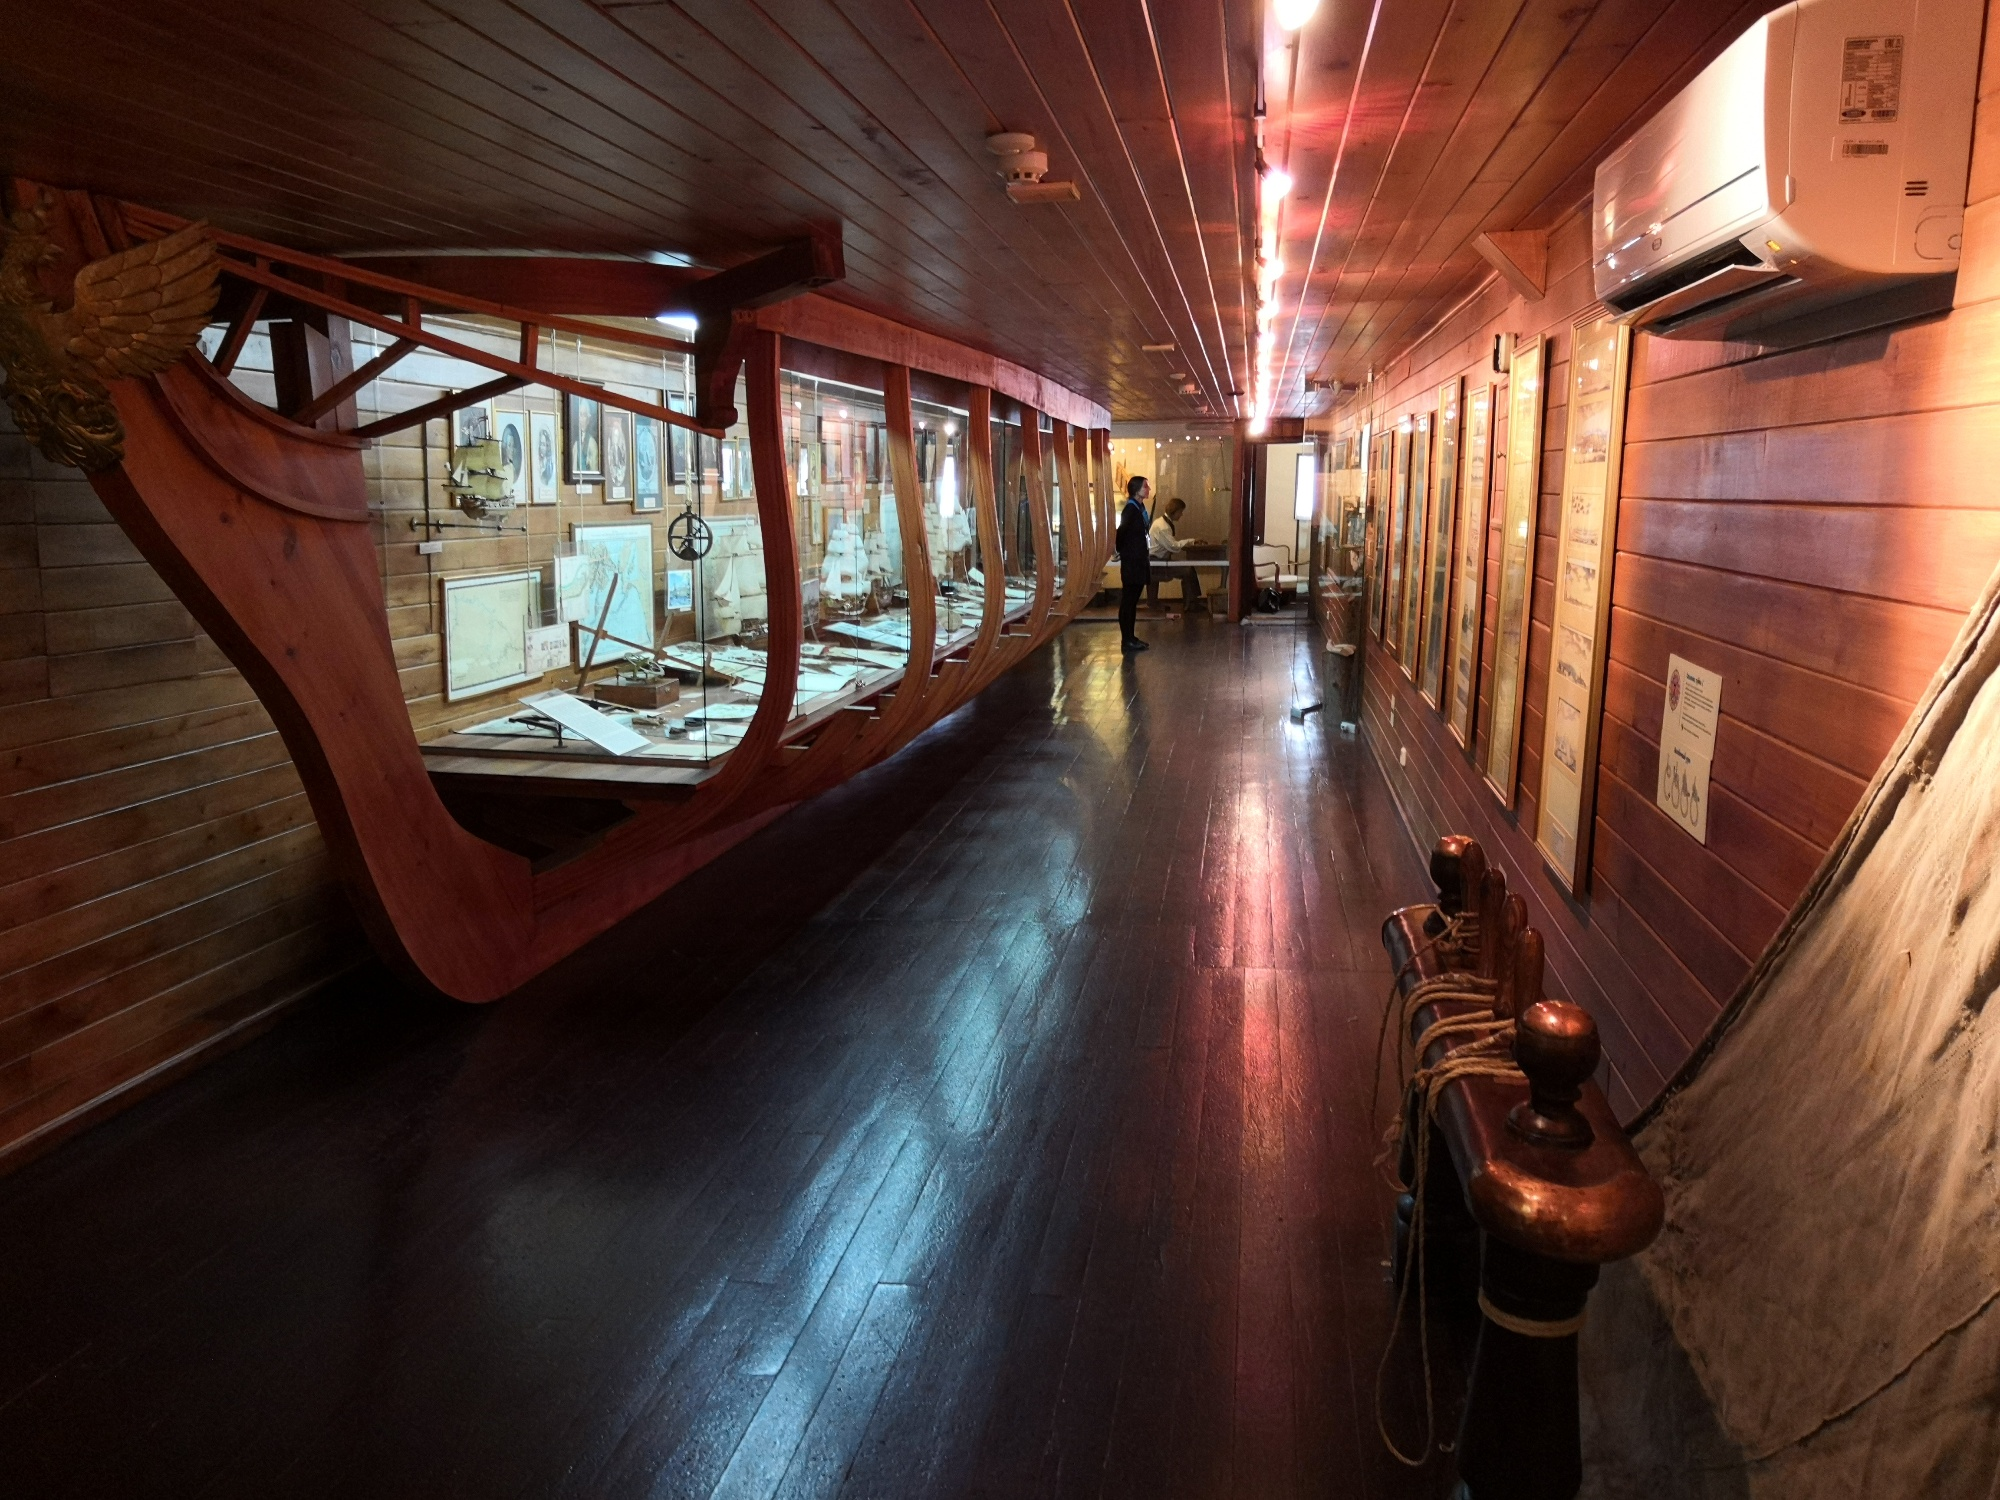What modern technology do you think helps preserve such exhibits today? Modern technology plays a crucial role in preserving historical exhibits like the one depicted. Climate control systems ensure that temperature and humidity levels are kept stable to prevent the deterioration of wooden artifacts and historical documents. Advanced lighting solutions minimize exposure to harmful UV rays while providing optimal viewing conditions. High-resolution imaging and 3D scanning technologies allow for precise documentation and virtual restoration of artifacts. Additionally, digital archives and interactive displays enable a broader audience to engage with the exhibits without physically handling sensitive items, thus preserving the original artifacts for future generations. 